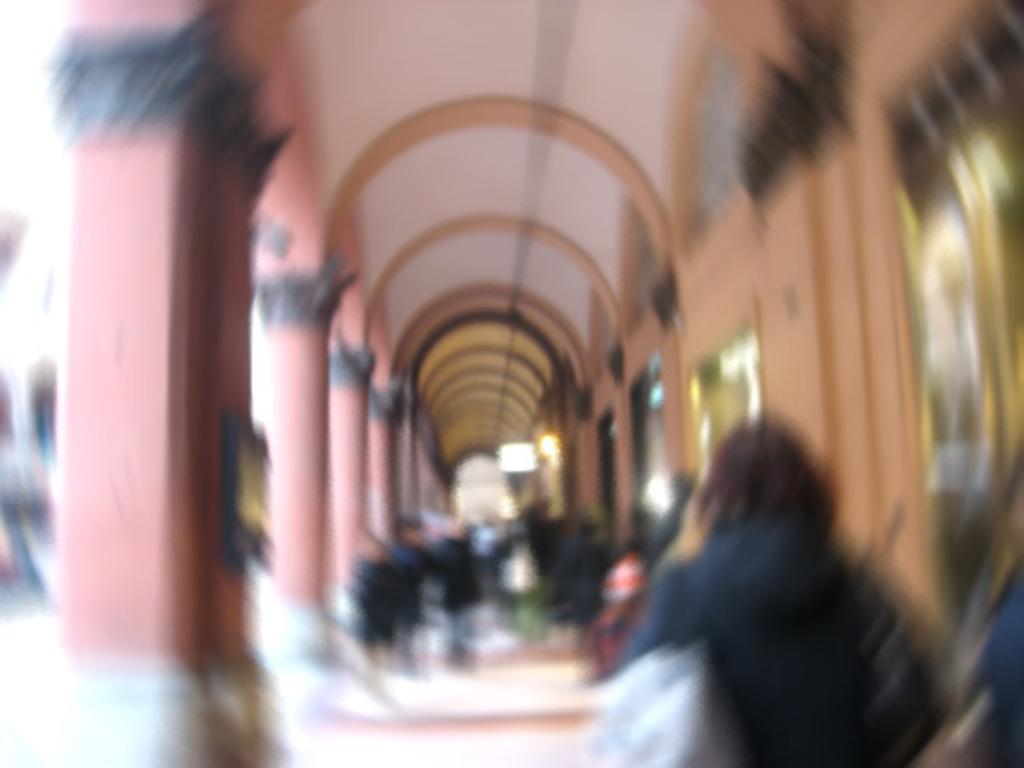Who or what can be seen in the image? There are people in the image. What architectural features are present in the image? There are pillars in the image. What is on the wall in the image? There is a wall with objects in the image. What part of the building can be seen in the image? The roof is visible in the image. What is the surface beneath the people and objects in the image? The ground is visible in the image. What type of cherry is being used to make the loaf in the image? There is no cherry or loaf present in the image. How does the person in the image plan to use the shake for their project? There is no shake or project involving a shake in the image. 